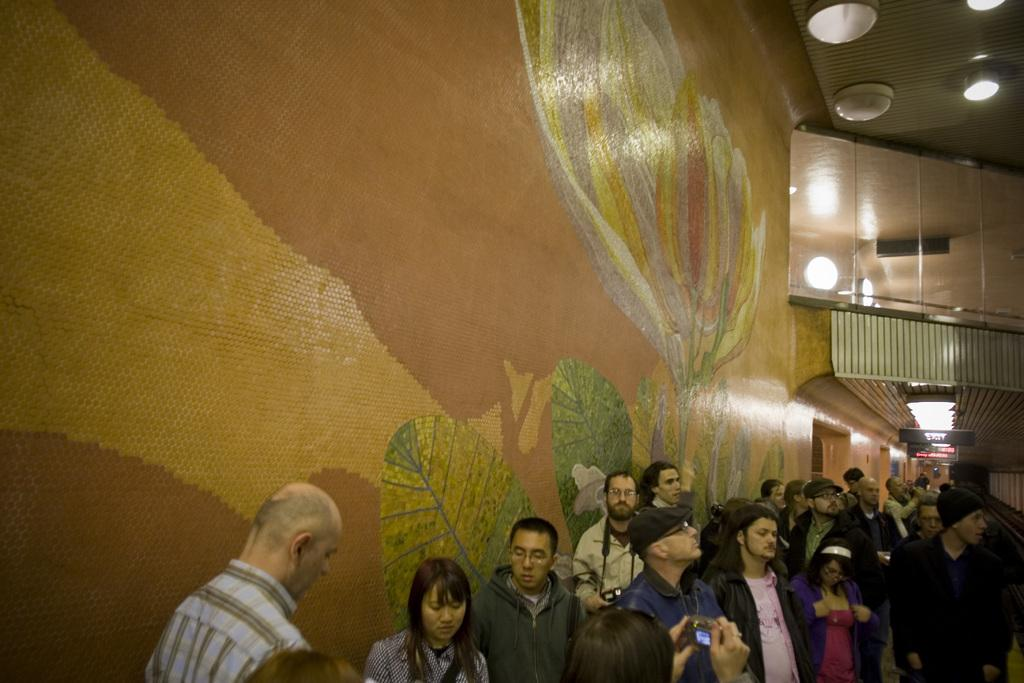What is the main subject of the image? The main subject of the image is a crowd. What structure is present in the image? There is a big wall in the image. What feature does the wall have? The wall has doors on it. What can be seen in the background of the image? There are screens visible in the background of the image. What type of arch can be seen in the image? There is no arch present in the image. How many rocks are visible in the image? There are no rocks visible in the image. 